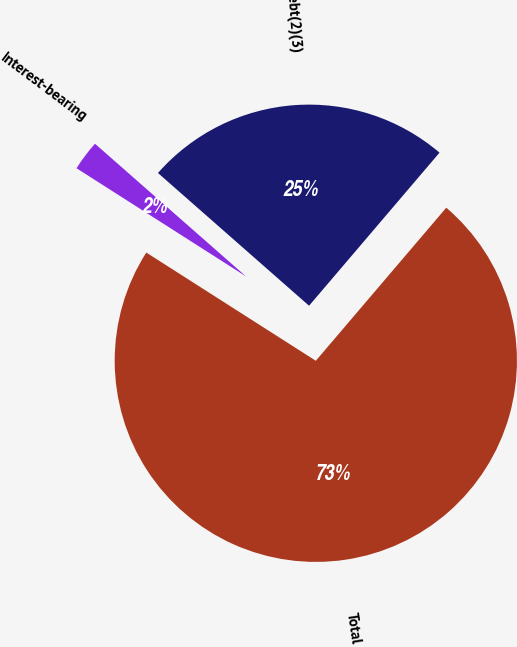Convert chart to OTSL. <chart><loc_0><loc_0><loc_500><loc_500><pie_chart><fcel>Interest-bearing<fcel>Long-term debt(2)(3)<fcel>Total<nl><fcel>2.43%<fcel>24.76%<fcel>72.81%<nl></chart> 